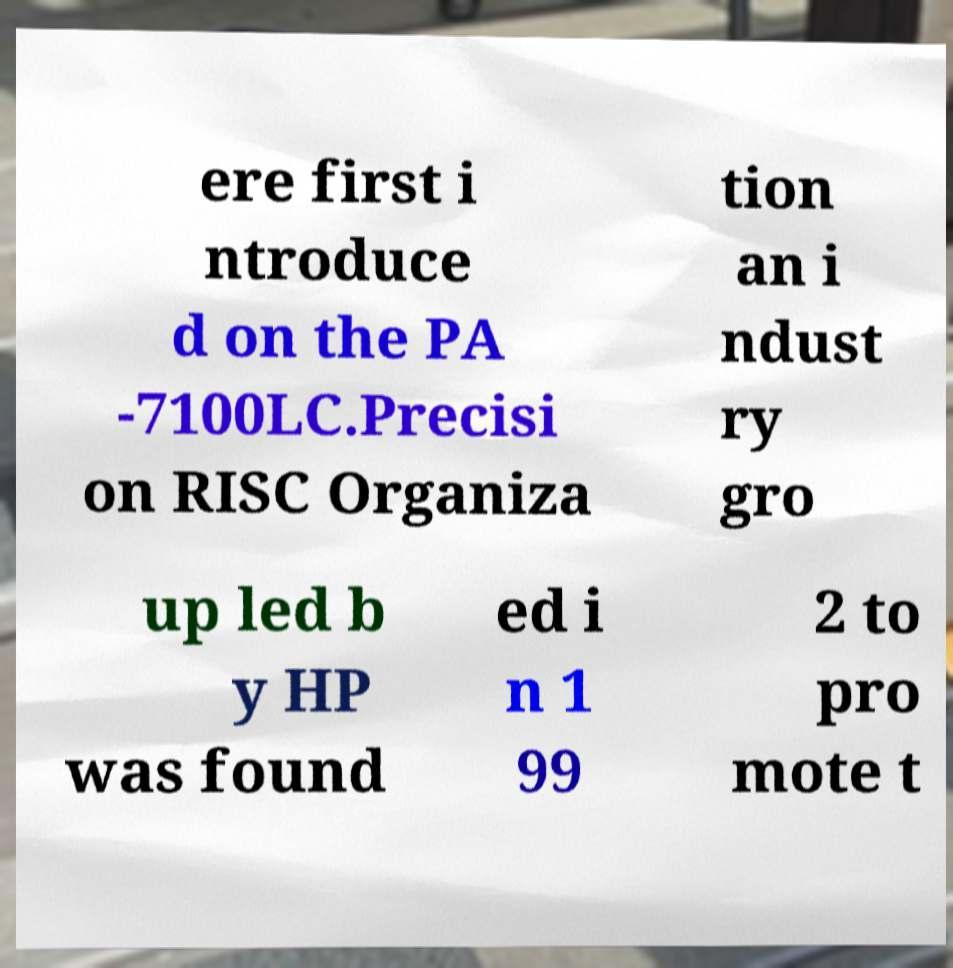Please identify and transcribe the text found in this image. ere first i ntroduce d on the PA -7100LC.Precisi on RISC Organiza tion an i ndust ry gro up led b y HP was found ed i n 1 99 2 to pro mote t 